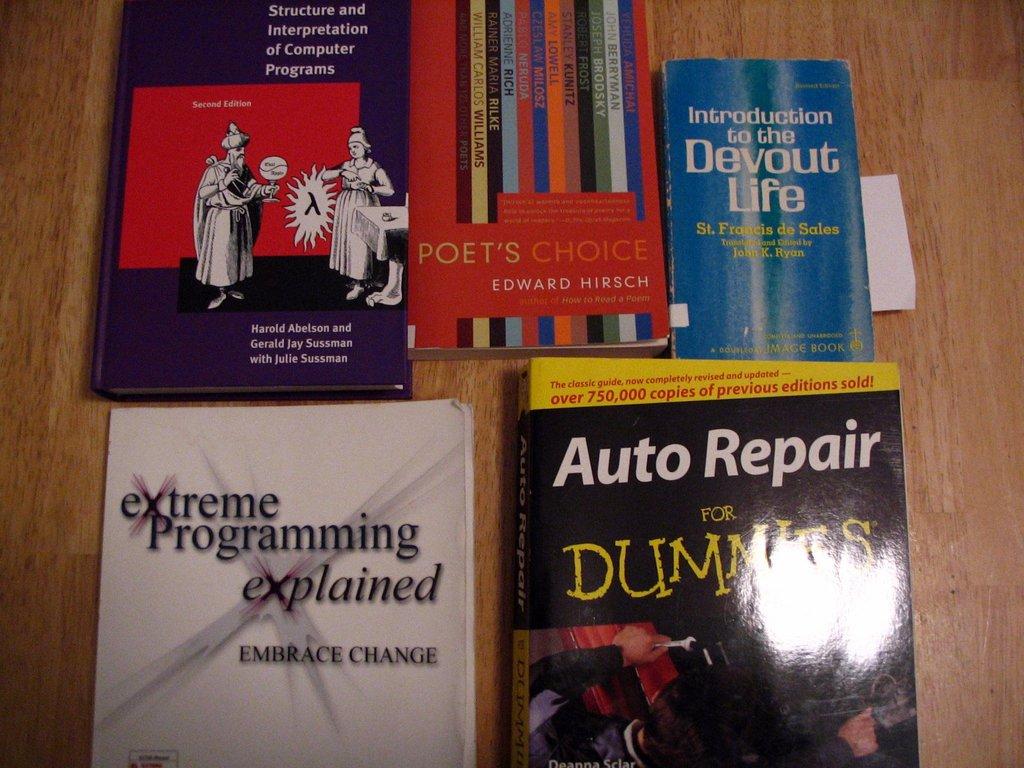What kind of life is the introduction to?
Offer a very short reply. Devout. 